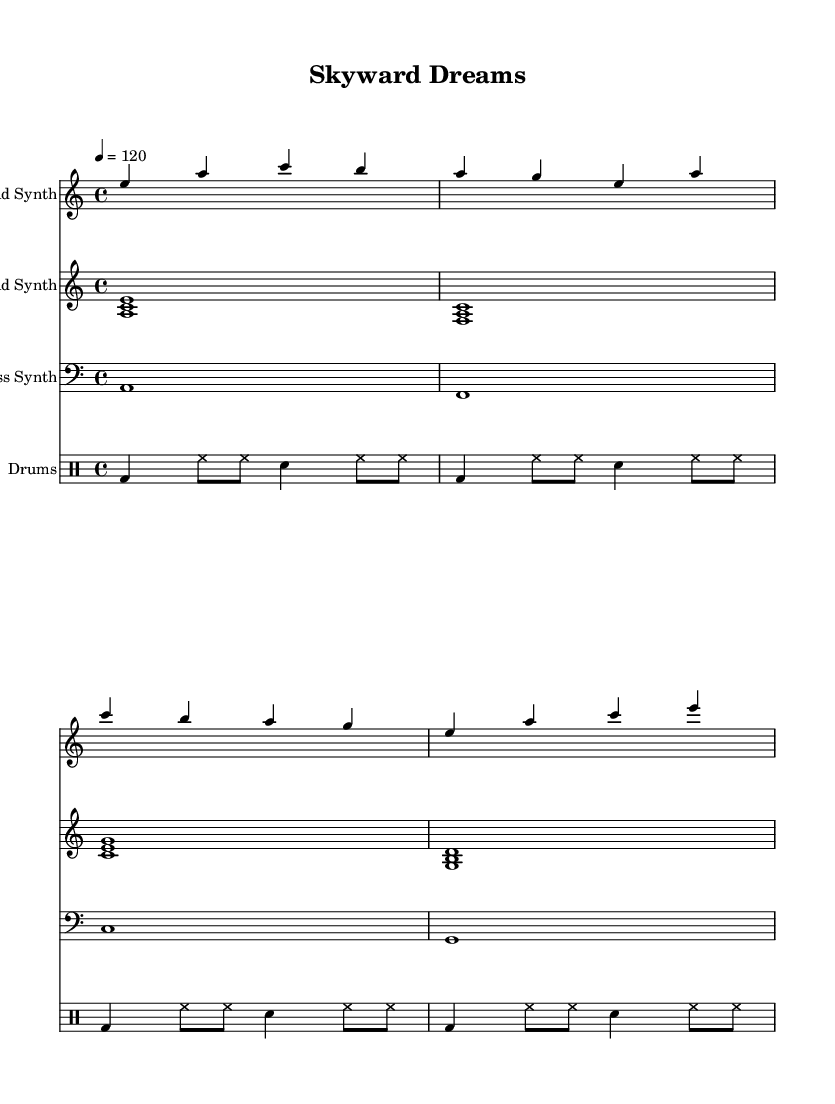What is the key signature of this music? The key signature is A minor, which has no sharps or flats.
Answer: A minor What is the time signature of this music? The time signature is indicated at the beginning of the piece and shows there are four beats in each measure.
Answer: 4/4 What is the tempo marking provided? The tempo marking indicates a speed of 120 beats per minute, meaning the music should be played quite briskly.
Answer: 120 How many voices are in the lead synth part? There is one voice listed for the lead synth part in the score, as indicated in the notation.
Answer: 1 Which synth is playing the harmony notes? The pad synth is indicated to play harmony notes that support the lead and bass parts, as seen in the staff labelled "Pad Synth".
Answer: Pad Synth What is the rhythm pattern of the drums in the first measure? The drum pattern in the first measure consists of a bass drum on the downbeat followed by hi-hats and a snare drum, creating a consistent rhythmic drive.
Answer: bd, hh, sn What is the lowest note being played in the bass synth? The lowest note in the bass synth staff is A, which is the note that forms the root of the bass line for the piece.
Answer: A 